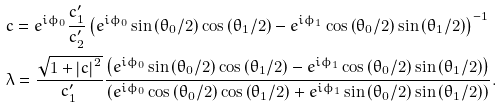Convert formula to latex. <formula><loc_0><loc_0><loc_500><loc_500>& c = e ^ { i \phi _ { 0 } } \frac { c _ { 1 } ^ { \prime } } { c _ { 2 } ^ { \prime } } \left ( e ^ { i \phi _ { 0 } } \sin \left ( \theta _ { 0 } / 2 \right ) \cos \left ( \theta _ { 1 } / 2 \right ) - e ^ { i \phi _ { 1 } } \cos \left ( \theta _ { 0 } / 2 \right ) \sin \left ( \theta _ { 1 } / 2 \right ) \right ) ^ { - 1 } \\ & \lambda = \frac { \sqrt { 1 + \left | c \right | ^ { 2 } } } { c _ { 1 } ^ { \prime } } \frac { \left ( e ^ { i \phi _ { 0 } } \sin \left ( \theta _ { 0 } / 2 \right ) \cos \left ( \theta _ { 1 } / 2 \right ) - e ^ { i \phi _ { 1 } } \cos \left ( \theta _ { 0 } / 2 \right ) \sin \left ( \theta _ { 1 } / 2 \right ) \right ) } { \left ( e ^ { i \phi _ { 0 } } \cos \left ( \theta _ { 0 } / 2 \right ) \cos \left ( \theta _ { 1 } / 2 \right ) + e ^ { i \phi _ { 1 } } \sin \left ( \theta _ { 0 } / 2 \right ) \sin \left ( \theta _ { 1 } / 2 \right ) \right ) } .</formula> 